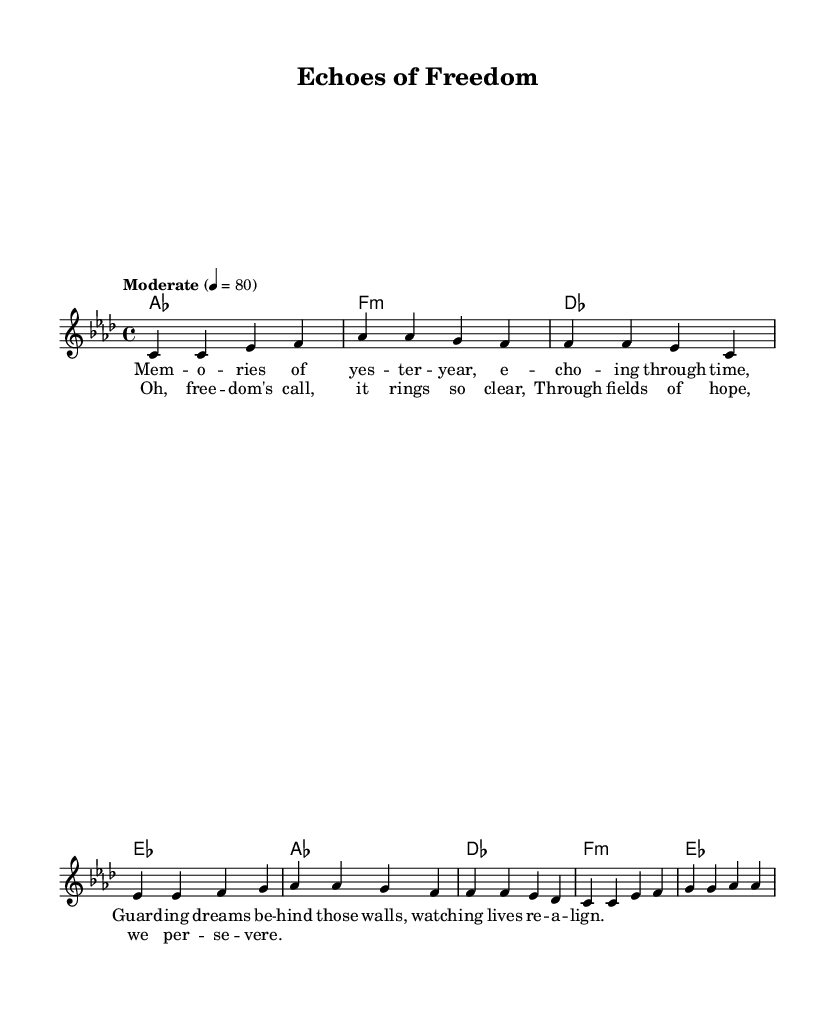What is the key signature of this music? The key signature is indicated by the presence of four sharps (F#, C#, G#, D#), which represents A-flat major.
Answer: A-flat major What is the time signature of the piece? The time signature is found at the beginning of the sheet music, represented by the numbers 4 over 4, indicating there are four beats in each measure.
Answer: 4/4 What is the tempo marking of this piece? The tempo marking, which shows how fast or slow the piece should be played, is indicated in the first line of the score as "Moderate" with a speed of 80 beats per minute.
Answer: Moderate How many measures are there in the melody? By counting the individual groups separated by the vertical lines (bar lines), there are 8 measures in the melody section.
Answer: 8 What is the main theme expressed in the lyrics of the verse? The lyrics reflect on memories and the guarding of dreams, suggesting themes of nostalgia and resilience, particularly in the context of a past experience.
Answer: Memories Which section contains the lyrics "Oh, freedom's call, it rings so clear"? This phrase appears in the chorus section, clearly marked in the song structure as separate from the verses.
Answer: Chorus What musical technique is primarily utilized in the harmonies? The harmonies are constructed using chord progressions typical for Rhythm and Blues, featuring major and minor chords that create a rich harmonic texture, using a mix of major and minor alterations to add depth.
Answer: Chord progressions 